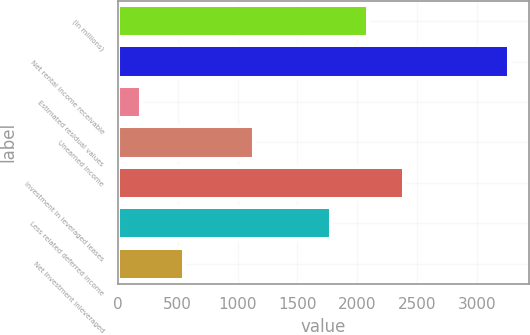<chart> <loc_0><loc_0><loc_500><loc_500><bar_chart><fcel>(In millions)<fcel>Net rental income receivable<fcel>Estimated residual values<fcel>Unearned income<fcel>Investment in leveraged leases<fcel>Less related deferred income<fcel>Net investment inleveraged<nl><fcel>2086.6<fcel>3272<fcel>196<fcel>1139<fcel>2394.2<fcel>1779<fcel>550<nl></chart> 